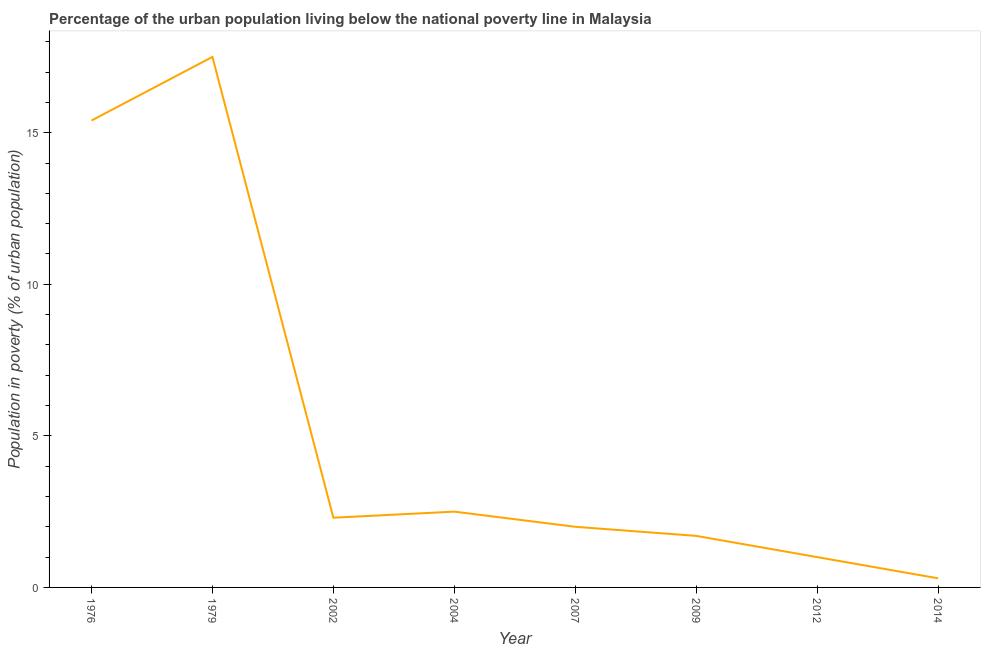What is the percentage of urban population living below poverty line in 2012?
Your response must be concise. 1. Across all years, what is the minimum percentage of urban population living below poverty line?
Your answer should be compact. 0.3. In which year was the percentage of urban population living below poverty line maximum?
Your answer should be very brief. 1979. What is the sum of the percentage of urban population living below poverty line?
Ensure brevity in your answer.  42.7. What is the average percentage of urban population living below poverty line per year?
Provide a short and direct response. 5.34. What is the median percentage of urban population living below poverty line?
Provide a succinct answer. 2.15. What is the ratio of the percentage of urban population living below poverty line in 1979 to that in 2007?
Ensure brevity in your answer.  8.75. Is the percentage of urban population living below poverty line in 2007 less than that in 2009?
Provide a short and direct response. No. What is the difference between the highest and the second highest percentage of urban population living below poverty line?
Give a very brief answer. 2.1. How many lines are there?
Your answer should be very brief. 1. What is the difference between two consecutive major ticks on the Y-axis?
Keep it short and to the point. 5. Are the values on the major ticks of Y-axis written in scientific E-notation?
Offer a very short reply. No. What is the title of the graph?
Offer a terse response. Percentage of the urban population living below the national poverty line in Malaysia. What is the label or title of the Y-axis?
Give a very brief answer. Population in poverty (% of urban population). What is the Population in poverty (% of urban population) in 1979?
Offer a terse response. 17.5. What is the Population in poverty (% of urban population) in 2012?
Ensure brevity in your answer.  1. What is the Population in poverty (% of urban population) of 2014?
Your answer should be compact. 0.3. What is the difference between the Population in poverty (% of urban population) in 1976 and 2002?
Offer a very short reply. 13.1. What is the difference between the Population in poverty (% of urban population) in 1976 and 2012?
Provide a short and direct response. 14.4. What is the difference between the Population in poverty (% of urban population) in 1976 and 2014?
Ensure brevity in your answer.  15.1. What is the difference between the Population in poverty (% of urban population) in 1979 and 2002?
Your response must be concise. 15.2. What is the difference between the Population in poverty (% of urban population) in 1979 and 2007?
Give a very brief answer. 15.5. What is the difference between the Population in poverty (% of urban population) in 1979 and 2009?
Make the answer very short. 15.8. What is the difference between the Population in poverty (% of urban population) in 1979 and 2012?
Offer a very short reply. 16.5. What is the difference between the Population in poverty (% of urban population) in 1979 and 2014?
Provide a short and direct response. 17.2. What is the difference between the Population in poverty (% of urban population) in 2002 and 2004?
Ensure brevity in your answer.  -0.2. What is the difference between the Population in poverty (% of urban population) in 2002 and 2014?
Make the answer very short. 2. What is the difference between the Population in poverty (% of urban population) in 2007 and 2009?
Your response must be concise. 0.3. What is the difference between the Population in poverty (% of urban population) in 2007 and 2012?
Your answer should be very brief. 1. What is the difference between the Population in poverty (% of urban population) in 2009 and 2014?
Keep it short and to the point. 1.4. What is the ratio of the Population in poverty (% of urban population) in 1976 to that in 1979?
Keep it short and to the point. 0.88. What is the ratio of the Population in poverty (% of urban population) in 1976 to that in 2002?
Keep it short and to the point. 6.7. What is the ratio of the Population in poverty (% of urban population) in 1976 to that in 2004?
Provide a short and direct response. 6.16. What is the ratio of the Population in poverty (% of urban population) in 1976 to that in 2007?
Offer a terse response. 7.7. What is the ratio of the Population in poverty (% of urban population) in 1976 to that in 2009?
Provide a succinct answer. 9.06. What is the ratio of the Population in poverty (% of urban population) in 1976 to that in 2014?
Keep it short and to the point. 51.33. What is the ratio of the Population in poverty (% of urban population) in 1979 to that in 2002?
Make the answer very short. 7.61. What is the ratio of the Population in poverty (% of urban population) in 1979 to that in 2004?
Give a very brief answer. 7. What is the ratio of the Population in poverty (% of urban population) in 1979 to that in 2007?
Make the answer very short. 8.75. What is the ratio of the Population in poverty (% of urban population) in 1979 to that in 2009?
Keep it short and to the point. 10.29. What is the ratio of the Population in poverty (% of urban population) in 1979 to that in 2014?
Provide a succinct answer. 58.33. What is the ratio of the Population in poverty (% of urban population) in 2002 to that in 2007?
Make the answer very short. 1.15. What is the ratio of the Population in poverty (% of urban population) in 2002 to that in 2009?
Make the answer very short. 1.35. What is the ratio of the Population in poverty (% of urban population) in 2002 to that in 2012?
Keep it short and to the point. 2.3. What is the ratio of the Population in poverty (% of urban population) in 2002 to that in 2014?
Make the answer very short. 7.67. What is the ratio of the Population in poverty (% of urban population) in 2004 to that in 2007?
Offer a terse response. 1.25. What is the ratio of the Population in poverty (% of urban population) in 2004 to that in 2009?
Offer a very short reply. 1.47. What is the ratio of the Population in poverty (% of urban population) in 2004 to that in 2012?
Provide a succinct answer. 2.5. What is the ratio of the Population in poverty (% of urban population) in 2004 to that in 2014?
Your answer should be very brief. 8.33. What is the ratio of the Population in poverty (% of urban population) in 2007 to that in 2009?
Your response must be concise. 1.18. What is the ratio of the Population in poverty (% of urban population) in 2007 to that in 2014?
Keep it short and to the point. 6.67. What is the ratio of the Population in poverty (% of urban population) in 2009 to that in 2014?
Your answer should be compact. 5.67. What is the ratio of the Population in poverty (% of urban population) in 2012 to that in 2014?
Give a very brief answer. 3.33. 